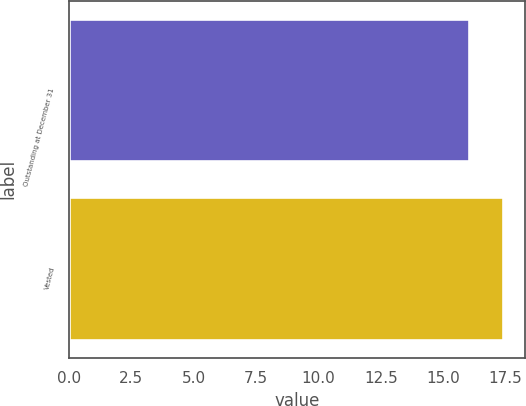Convert chart to OTSL. <chart><loc_0><loc_0><loc_500><loc_500><bar_chart><fcel>Outstanding at December 31<fcel>Vested<nl><fcel>16.04<fcel>17.4<nl></chart> 